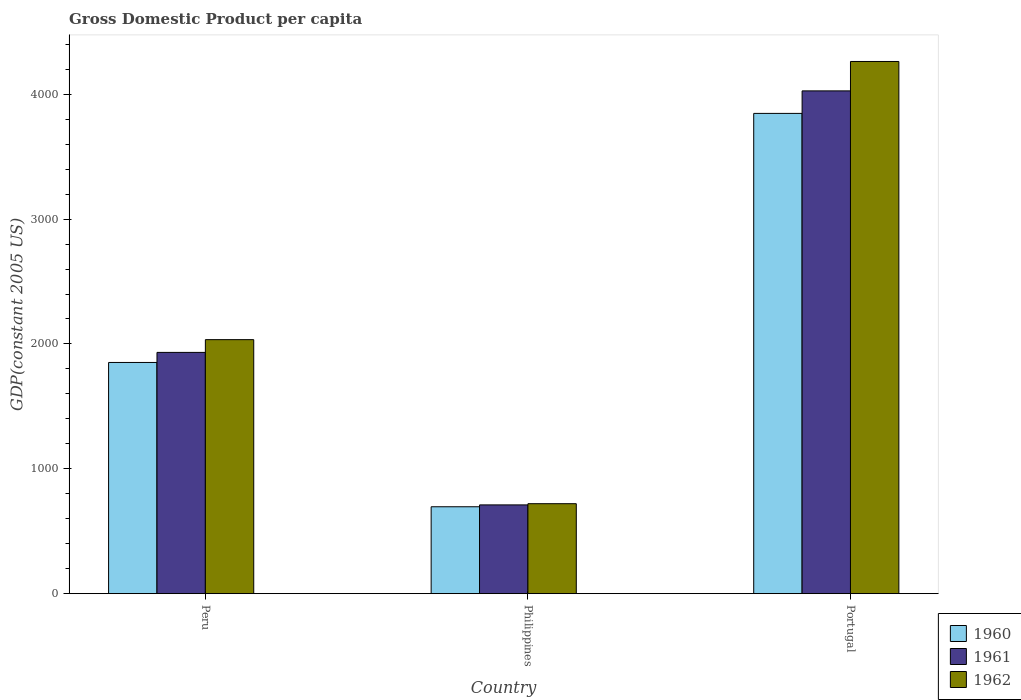How many groups of bars are there?
Make the answer very short. 3. How many bars are there on the 1st tick from the right?
Ensure brevity in your answer.  3. In how many cases, is the number of bars for a given country not equal to the number of legend labels?
Provide a succinct answer. 0. What is the GDP per capita in 1962 in Portugal?
Offer a terse response. 4262.56. Across all countries, what is the maximum GDP per capita in 1960?
Offer a very short reply. 3846.7. Across all countries, what is the minimum GDP per capita in 1961?
Your answer should be very brief. 710.98. What is the total GDP per capita in 1962 in the graph?
Offer a very short reply. 7017.7. What is the difference between the GDP per capita in 1962 in Philippines and that in Portugal?
Ensure brevity in your answer.  -3541.95. What is the difference between the GDP per capita in 1962 in Peru and the GDP per capita in 1961 in Portugal?
Your response must be concise. -1992.52. What is the average GDP per capita in 1962 per country?
Keep it short and to the point. 2339.23. What is the difference between the GDP per capita of/in 1960 and GDP per capita of/in 1961 in Peru?
Offer a terse response. -80.65. What is the ratio of the GDP per capita in 1962 in Peru to that in Philippines?
Offer a terse response. 2.82. Is the GDP per capita in 1961 in Peru less than that in Portugal?
Your answer should be compact. Yes. What is the difference between the highest and the second highest GDP per capita in 1960?
Your response must be concise. -1155.75. What is the difference between the highest and the lowest GDP per capita in 1961?
Provide a short and direct response. 3316.08. In how many countries, is the GDP per capita in 1962 greater than the average GDP per capita in 1962 taken over all countries?
Provide a succinct answer. 1. What does the 1st bar from the left in Philippines represents?
Your answer should be compact. 1960. What does the 1st bar from the right in Portugal represents?
Keep it short and to the point. 1962. How many bars are there?
Make the answer very short. 9. What is the difference between two consecutive major ticks on the Y-axis?
Your answer should be very brief. 1000. Are the values on the major ticks of Y-axis written in scientific E-notation?
Provide a succinct answer. No. Where does the legend appear in the graph?
Offer a terse response. Bottom right. How many legend labels are there?
Your answer should be very brief. 3. What is the title of the graph?
Provide a short and direct response. Gross Domestic Product per capita. What is the label or title of the X-axis?
Your answer should be compact. Country. What is the label or title of the Y-axis?
Make the answer very short. GDP(constant 2005 US). What is the GDP(constant 2005 US) of 1960 in Peru?
Make the answer very short. 1851.77. What is the GDP(constant 2005 US) in 1961 in Peru?
Keep it short and to the point. 1932.43. What is the GDP(constant 2005 US) in 1962 in Peru?
Offer a terse response. 2034.54. What is the GDP(constant 2005 US) in 1960 in Philippines?
Offer a terse response. 696.02. What is the GDP(constant 2005 US) of 1961 in Philippines?
Ensure brevity in your answer.  710.98. What is the GDP(constant 2005 US) in 1962 in Philippines?
Your answer should be compact. 720.61. What is the GDP(constant 2005 US) in 1960 in Portugal?
Offer a terse response. 3846.7. What is the GDP(constant 2005 US) of 1961 in Portugal?
Give a very brief answer. 4027.06. What is the GDP(constant 2005 US) of 1962 in Portugal?
Provide a succinct answer. 4262.56. Across all countries, what is the maximum GDP(constant 2005 US) in 1960?
Your answer should be very brief. 3846.7. Across all countries, what is the maximum GDP(constant 2005 US) of 1961?
Your answer should be very brief. 4027.06. Across all countries, what is the maximum GDP(constant 2005 US) of 1962?
Your response must be concise. 4262.56. Across all countries, what is the minimum GDP(constant 2005 US) in 1960?
Your answer should be compact. 696.02. Across all countries, what is the minimum GDP(constant 2005 US) in 1961?
Keep it short and to the point. 710.98. Across all countries, what is the minimum GDP(constant 2005 US) in 1962?
Offer a very short reply. 720.61. What is the total GDP(constant 2005 US) of 1960 in the graph?
Your answer should be very brief. 6394.49. What is the total GDP(constant 2005 US) in 1961 in the graph?
Your answer should be compact. 6670.47. What is the total GDP(constant 2005 US) in 1962 in the graph?
Provide a short and direct response. 7017.7. What is the difference between the GDP(constant 2005 US) in 1960 in Peru and that in Philippines?
Your answer should be very brief. 1155.75. What is the difference between the GDP(constant 2005 US) in 1961 in Peru and that in Philippines?
Give a very brief answer. 1221.44. What is the difference between the GDP(constant 2005 US) of 1962 in Peru and that in Philippines?
Offer a terse response. 1313.93. What is the difference between the GDP(constant 2005 US) of 1960 in Peru and that in Portugal?
Keep it short and to the point. -1994.93. What is the difference between the GDP(constant 2005 US) of 1961 in Peru and that in Portugal?
Make the answer very short. -2094.64. What is the difference between the GDP(constant 2005 US) in 1962 in Peru and that in Portugal?
Your answer should be compact. -2228.02. What is the difference between the GDP(constant 2005 US) in 1960 in Philippines and that in Portugal?
Your answer should be very brief. -3150.68. What is the difference between the GDP(constant 2005 US) in 1961 in Philippines and that in Portugal?
Give a very brief answer. -3316.08. What is the difference between the GDP(constant 2005 US) in 1962 in Philippines and that in Portugal?
Keep it short and to the point. -3541.95. What is the difference between the GDP(constant 2005 US) of 1960 in Peru and the GDP(constant 2005 US) of 1961 in Philippines?
Your answer should be compact. 1140.79. What is the difference between the GDP(constant 2005 US) in 1960 in Peru and the GDP(constant 2005 US) in 1962 in Philippines?
Your answer should be compact. 1131.17. What is the difference between the GDP(constant 2005 US) of 1961 in Peru and the GDP(constant 2005 US) of 1962 in Philippines?
Give a very brief answer. 1211.82. What is the difference between the GDP(constant 2005 US) in 1960 in Peru and the GDP(constant 2005 US) in 1961 in Portugal?
Give a very brief answer. -2175.29. What is the difference between the GDP(constant 2005 US) in 1960 in Peru and the GDP(constant 2005 US) in 1962 in Portugal?
Your response must be concise. -2410.79. What is the difference between the GDP(constant 2005 US) of 1961 in Peru and the GDP(constant 2005 US) of 1962 in Portugal?
Make the answer very short. -2330.13. What is the difference between the GDP(constant 2005 US) in 1960 in Philippines and the GDP(constant 2005 US) in 1961 in Portugal?
Offer a very short reply. -3331.04. What is the difference between the GDP(constant 2005 US) of 1960 in Philippines and the GDP(constant 2005 US) of 1962 in Portugal?
Make the answer very short. -3566.54. What is the difference between the GDP(constant 2005 US) of 1961 in Philippines and the GDP(constant 2005 US) of 1962 in Portugal?
Your response must be concise. -3551.57. What is the average GDP(constant 2005 US) of 1960 per country?
Provide a short and direct response. 2131.5. What is the average GDP(constant 2005 US) of 1961 per country?
Provide a succinct answer. 2223.49. What is the average GDP(constant 2005 US) of 1962 per country?
Your answer should be very brief. 2339.23. What is the difference between the GDP(constant 2005 US) of 1960 and GDP(constant 2005 US) of 1961 in Peru?
Your answer should be very brief. -80.65. What is the difference between the GDP(constant 2005 US) in 1960 and GDP(constant 2005 US) in 1962 in Peru?
Offer a terse response. -182.77. What is the difference between the GDP(constant 2005 US) of 1961 and GDP(constant 2005 US) of 1962 in Peru?
Provide a short and direct response. -102.11. What is the difference between the GDP(constant 2005 US) of 1960 and GDP(constant 2005 US) of 1961 in Philippines?
Keep it short and to the point. -14.96. What is the difference between the GDP(constant 2005 US) of 1960 and GDP(constant 2005 US) of 1962 in Philippines?
Your response must be concise. -24.59. What is the difference between the GDP(constant 2005 US) of 1961 and GDP(constant 2005 US) of 1962 in Philippines?
Ensure brevity in your answer.  -9.62. What is the difference between the GDP(constant 2005 US) in 1960 and GDP(constant 2005 US) in 1961 in Portugal?
Ensure brevity in your answer.  -180.36. What is the difference between the GDP(constant 2005 US) of 1960 and GDP(constant 2005 US) of 1962 in Portugal?
Offer a very short reply. -415.86. What is the difference between the GDP(constant 2005 US) in 1961 and GDP(constant 2005 US) in 1962 in Portugal?
Make the answer very short. -235.5. What is the ratio of the GDP(constant 2005 US) of 1960 in Peru to that in Philippines?
Provide a succinct answer. 2.66. What is the ratio of the GDP(constant 2005 US) of 1961 in Peru to that in Philippines?
Your response must be concise. 2.72. What is the ratio of the GDP(constant 2005 US) in 1962 in Peru to that in Philippines?
Give a very brief answer. 2.82. What is the ratio of the GDP(constant 2005 US) in 1960 in Peru to that in Portugal?
Make the answer very short. 0.48. What is the ratio of the GDP(constant 2005 US) of 1961 in Peru to that in Portugal?
Offer a very short reply. 0.48. What is the ratio of the GDP(constant 2005 US) in 1962 in Peru to that in Portugal?
Ensure brevity in your answer.  0.48. What is the ratio of the GDP(constant 2005 US) in 1960 in Philippines to that in Portugal?
Offer a terse response. 0.18. What is the ratio of the GDP(constant 2005 US) of 1961 in Philippines to that in Portugal?
Provide a succinct answer. 0.18. What is the ratio of the GDP(constant 2005 US) in 1962 in Philippines to that in Portugal?
Offer a very short reply. 0.17. What is the difference between the highest and the second highest GDP(constant 2005 US) of 1960?
Provide a short and direct response. 1994.93. What is the difference between the highest and the second highest GDP(constant 2005 US) of 1961?
Keep it short and to the point. 2094.64. What is the difference between the highest and the second highest GDP(constant 2005 US) in 1962?
Make the answer very short. 2228.02. What is the difference between the highest and the lowest GDP(constant 2005 US) in 1960?
Give a very brief answer. 3150.68. What is the difference between the highest and the lowest GDP(constant 2005 US) in 1961?
Provide a succinct answer. 3316.08. What is the difference between the highest and the lowest GDP(constant 2005 US) of 1962?
Provide a succinct answer. 3541.95. 